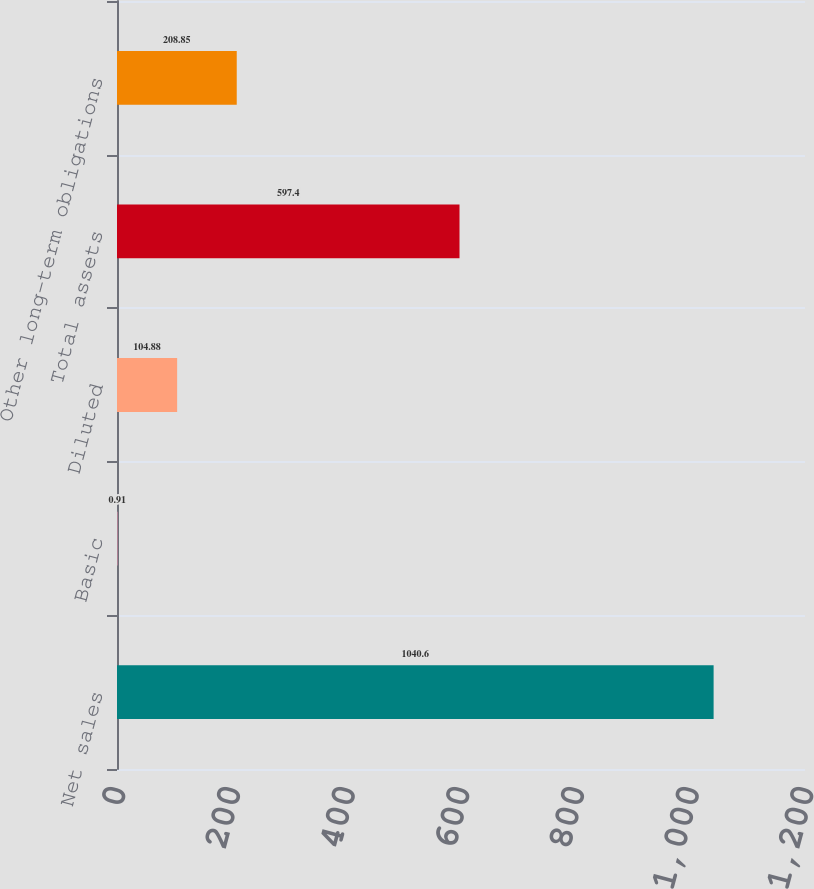Convert chart. <chart><loc_0><loc_0><loc_500><loc_500><bar_chart><fcel>Net sales<fcel>Basic<fcel>Diluted<fcel>Total assets<fcel>Other long-term obligations<nl><fcel>1040.6<fcel>0.91<fcel>104.88<fcel>597.4<fcel>208.85<nl></chart> 